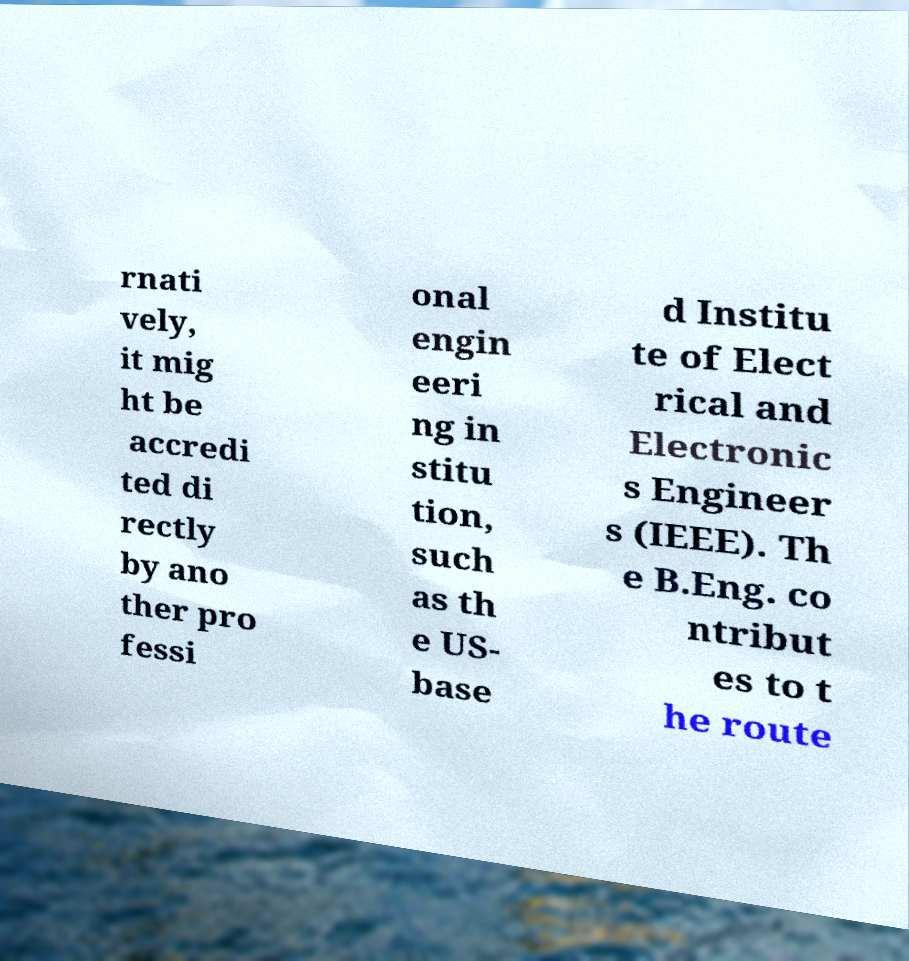There's text embedded in this image that I need extracted. Can you transcribe it verbatim? rnati vely, it mig ht be accredi ted di rectly by ano ther pro fessi onal engin eeri ng in stitu tion, such as th e US- base d Institu te of Elect rical and Electronic s Engineer s (IEEE). Th e B.Eng. co ntribut es to t he route 